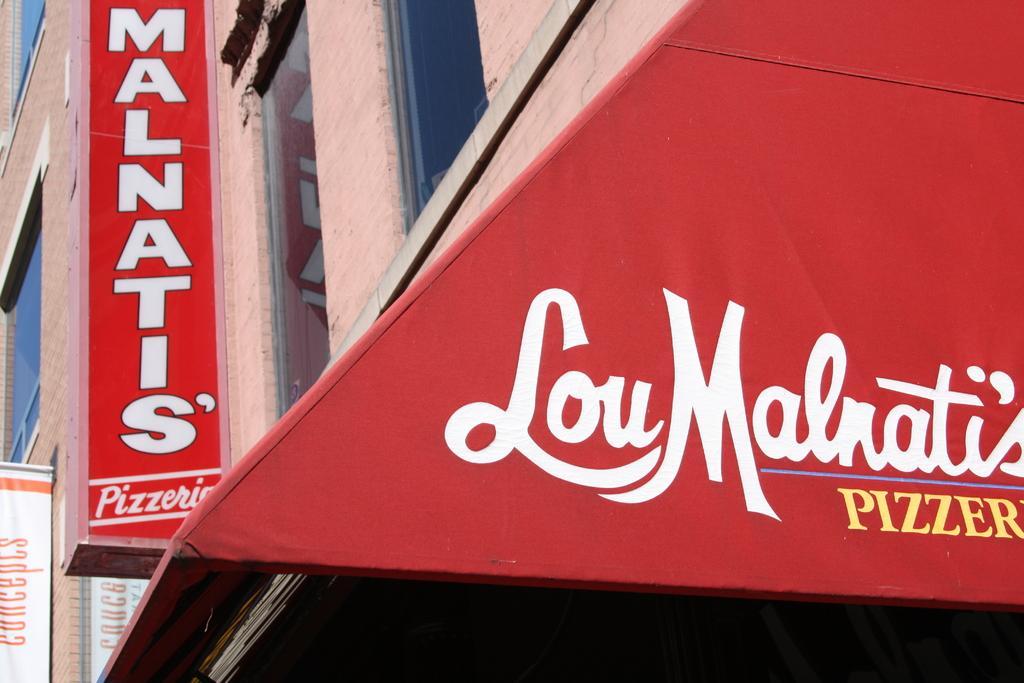How would you summarize this image in a sentence or two? Here in this picture we can see a building with number of windows present over a place and on the left side we can see a hoarding and a banner present and in the front we can see a tent like structure that is covered with the banners. 